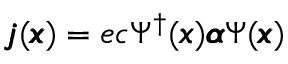Convert formula to latex. <formula><loc_0><loc_0><loc_500><loc_500>\pm b { j } ( \pm b { x } ) = e c \Psi ^ { \dagger } ( \pm b { x } ) \pm b { \alpha } \Psi ( \pm b { x } )</formula> 